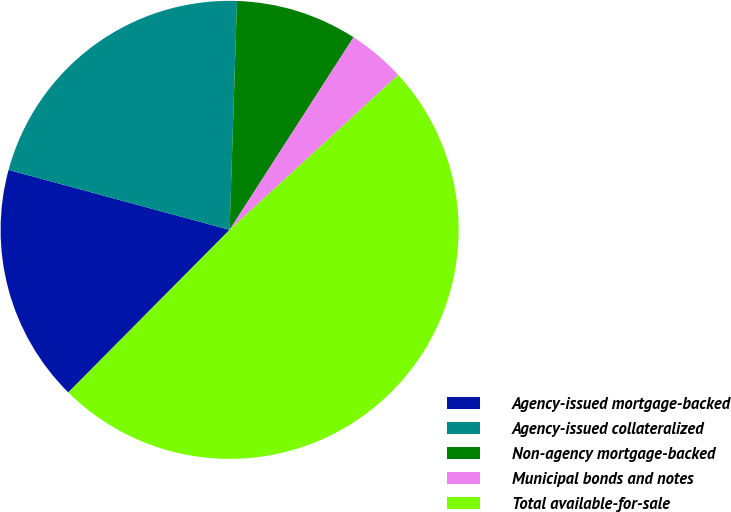Convert chart to OTSL. <chart><loc_0><loc_0><loc_500><loc_500><pie_chart><fcel>Agency-issued mortgage-backed<fcel>Agency-issued collateralized<fcel>Non-agency mortgage-backed<fcel>Municipal bonds and notes<fcel>Total available-for-sale<nl><fcel>16.78%<fcel>21.3%<fcel>8.59%<fcel>4.07%<fcel>49.27%<nl></chart> 